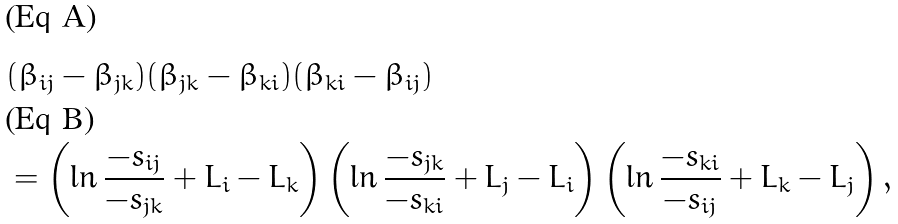Convert formula to latex. <formula><loc_0><loc_0><loc_500><loc_500>& ( \beta _ { i j } - \beta _ { j k } ) ( \beta _ { j k } - \beta _ { k i } ) ( \beta _ { k i } - \beta _ { i j } ) \\ & = \left ( \ln \frac { - s _ { i j } } { - s _ { j k } } + L _ { i } - L _ { k } \right ) \left ( \ln \frac { - s _ { j k } } { - s _ { k i } } + L _ { j } - L _ { i } \right ) \left ( \ln \frac { - s _ { k i } } { - s _ { i j } } + L _ { k } - L _ { j } \right ) ,</formula> 